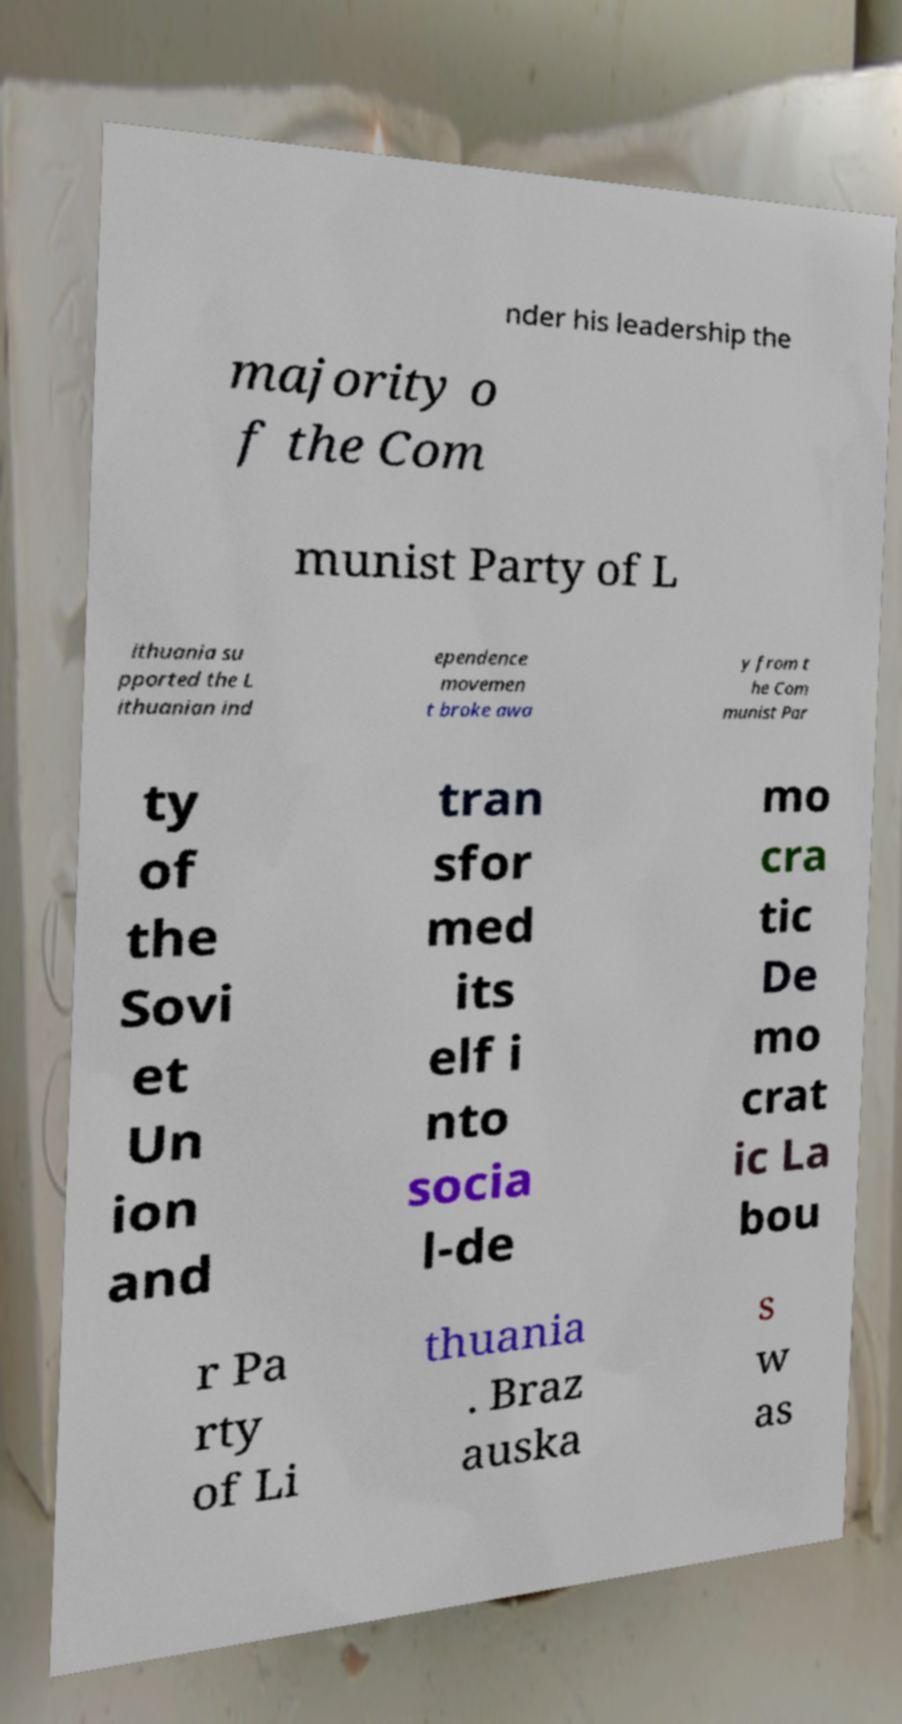I need the written content from this picture converted into text. Can you do that? nder his leadership the majority o f the Com munist Party of L ithuania su pported the L ithuanian ind ependence movemen t broke awa y from t he Com munist Par ty of the Sovi et Un ion and tran sfor med its elf i nto socia l-de mo cra tic De mo crat ic La bou r Pa rty of Li thuania . Braz auska s w as 